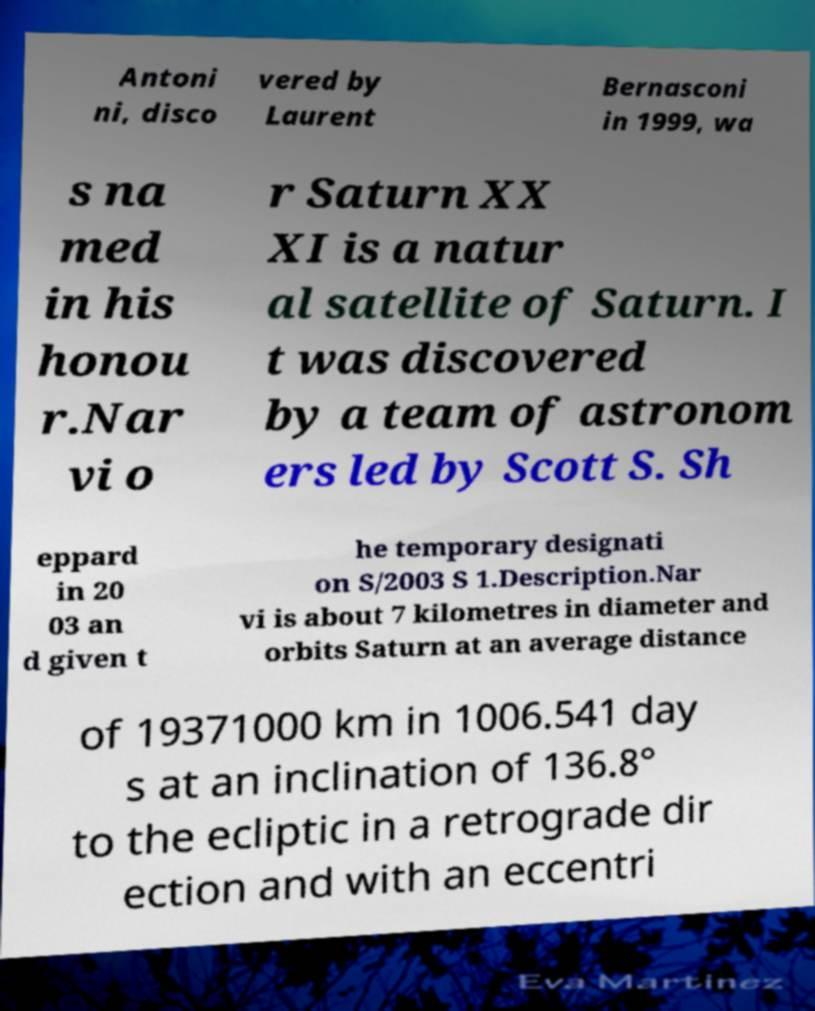Can you read and provide the text displayed in the image?This photo seems to have some interesting text. Can you extract and type it out for me? Antoni ni, disco vered by Laurent Bernasconi in 1999, wa s na med in his honou r.Nar vi o r Saturn XX XI is a natur al satellite of Saturn. I t was discovered by a team of astronom ers led by Scott S. Sh eppard in 20 03 an d given t he temporary designati on S/2003 S 1.Description.Nar vi is about 7 kilometres in diameter and orbits Saturn at an average distance of 19371000 km in 1006.541 day s at an inclination of 136.8° to the ecliptic in a retrograde dir ection and with an eccentri 